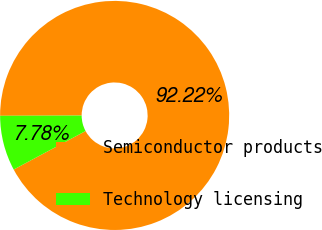<chart> <loc_0><loc_0><loc_500><loc_500><pie_chart><fcel>Semiconductor products<fcel>Technology licensing<nl><fcel>92.22%<fcel>7.78%<nl></chart> 